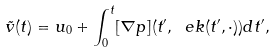Convert formula to latex. <formula><loc_0><loc_0><loc_500><loc_500>\tilde { v } ( t ) = u _ { 0 } + \int _ { 0 } ^ { t } [ \nabla p ] ( t ^ { \prime } , \ e k ( t ^ { \prime } , \cdot ) ) d t ^ { \prime } ,</formula> 